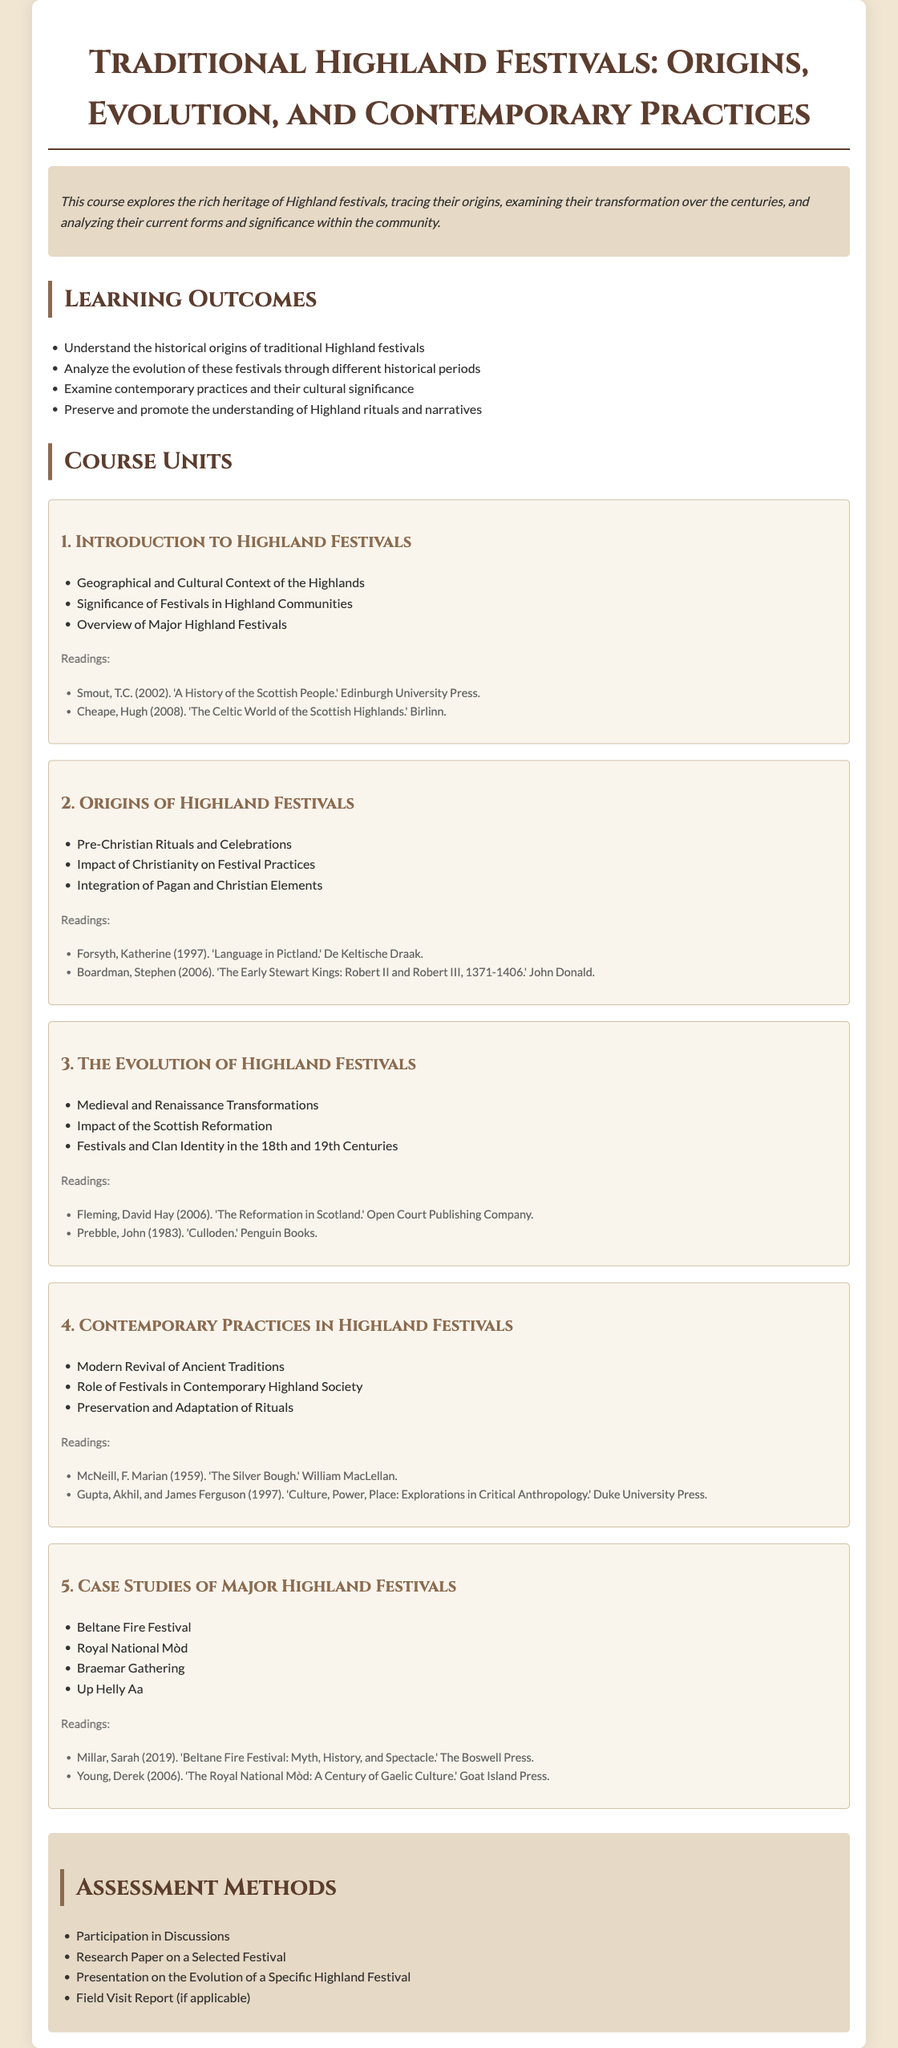what is the title of the course? The title of the course is provided at the top of the syllabus.
Answer: Traditional Highland Festivals: Origins, Evolution, and Contemporary Practices what is the focus of the course? The course description indicates what the course will explore.
Answer: Highland festivals heritage how many learning outcomes are listed? The number of learning outcomes is specified in the learning outcomes section.
Answer: Four what is the first unit of the course? The first unit title is located under the course units section.
Answer: Introduction to Highland Festivals which festival is associated with modern revival? The contemporary practices section refers to the revival in relation to festivals.
Answer: Ancient Traditions name one reading associated with Unit 2. The readings for Unit 2 are listed right under the unit title and details.
Answer: Forsyth, Katherine (1997). 'Language in Pictland.' what assessment method involves research? The assessment methods section lists various ways students will be evaluated.
Answer: Research Paper on a Selected Festival which festival is mentioned as a case study in the syllabus? The case studies section lists major festivals included in the syllabus.
Answer: Beltane Fire Festival 